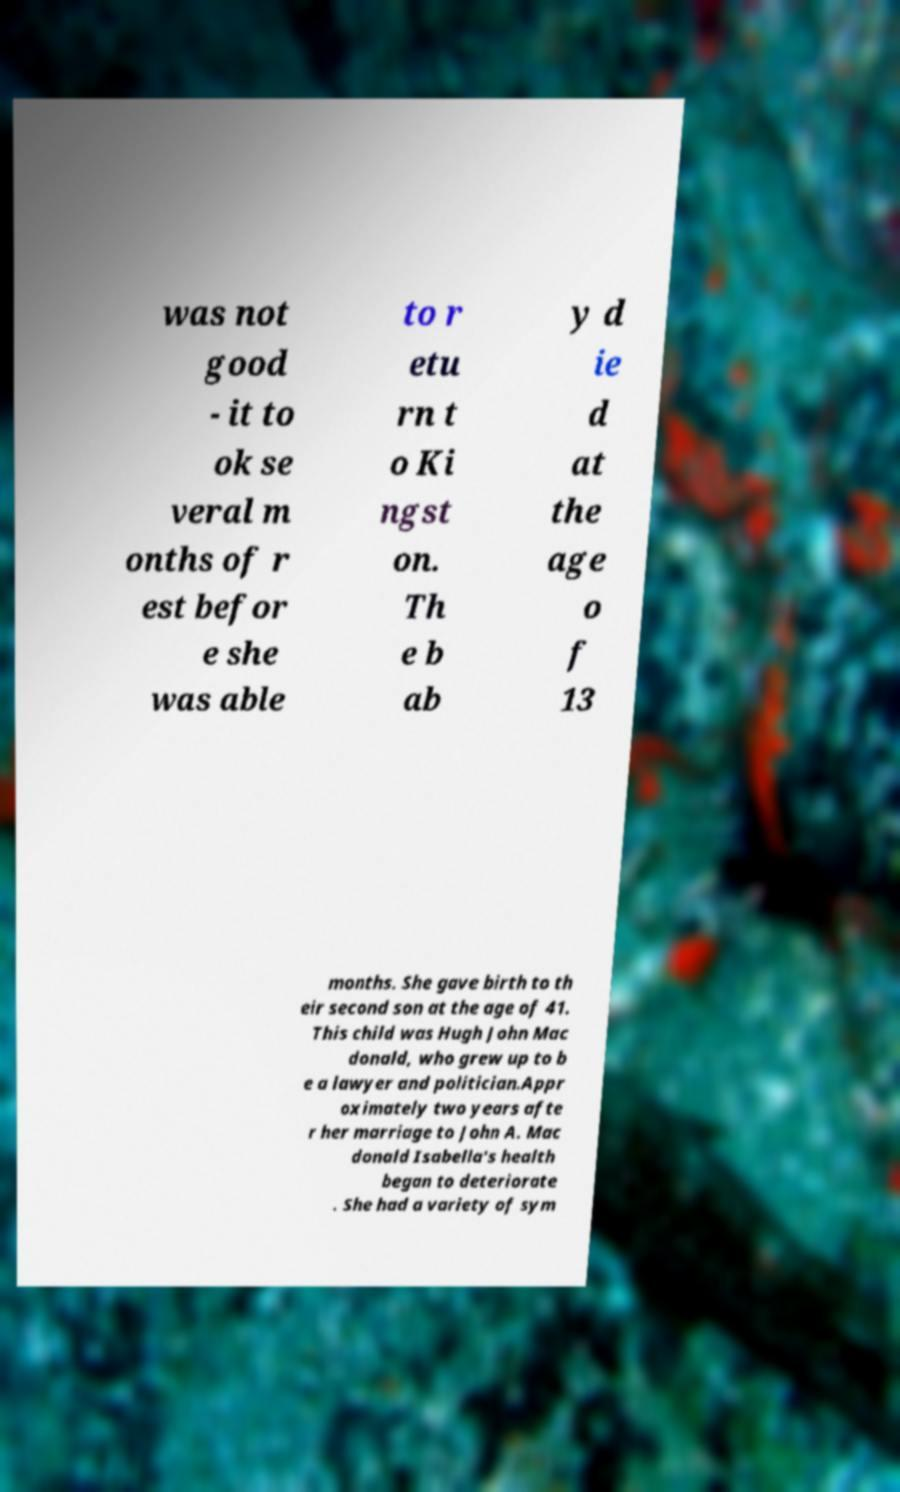What messages or text are displayed in this image? I need them in a readable, typed format. was not good - it to ok se veral m onths of r est befor e she was able to r etu rn t o Ki ngst on. Th e b ab y d ie d at the age o f 13 months. She gave birth to th eir second son at the age of 41. This child was Hugh John Mac donald, who grew up to b e a lawyer and politician.Appr oximately two years afte r her marriage to John A. Mac donald Isabella's health began to deteriorate . She had a variety of sym 